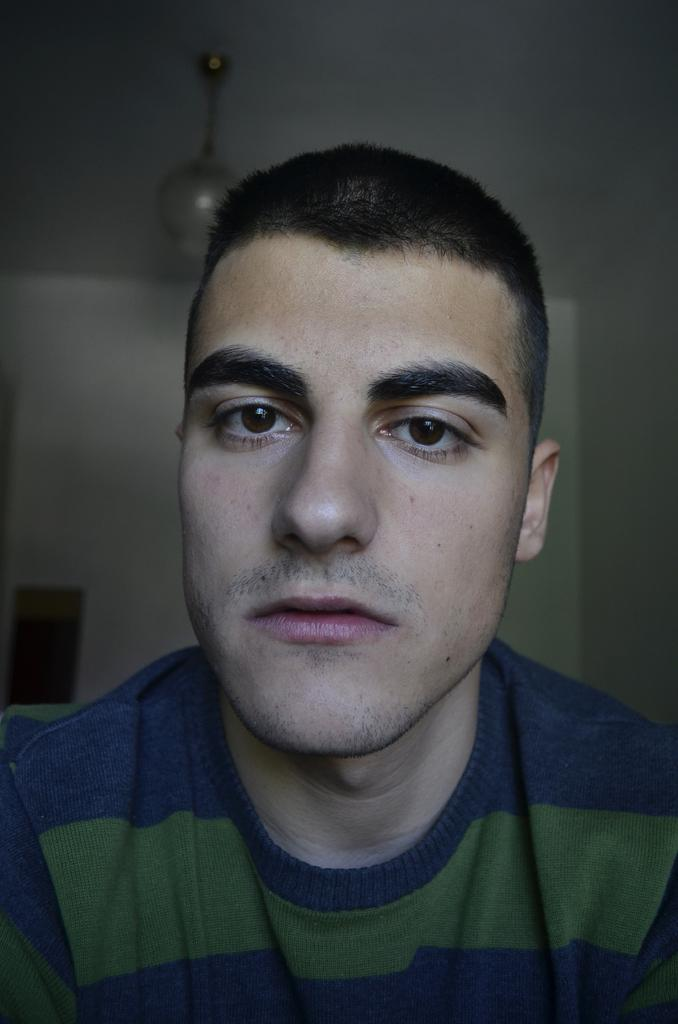What is the main subject of the image? There is a person in the image. What type of lighting is present in the image? There is a lamp hanging from the roof in the image. What can be seen attached to the wall on the left side of the image? There is a frame attached to the wall on the left side of the image. What is the person's annual income in the image? There is no information about the person's income in the image. What word is written on the frame in the image? There is no text or word visible on the frame in the image. 